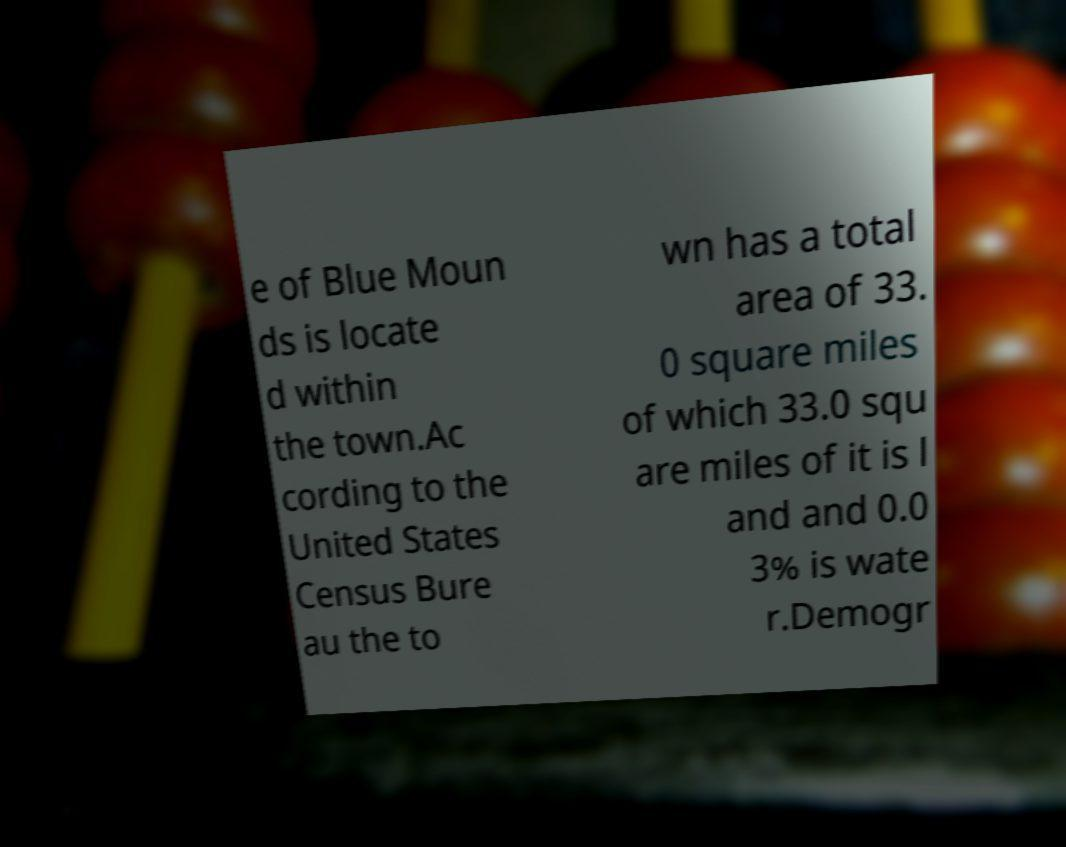Could you assist in decoding the text presented in this image and type it out clearly? e of Blue Moun ds is locate d within the town.Ac cording to the United States Census Bure au the to wn has a total area of 33. 0 square miles of which 33.0 squ are miles of it is l and and 0.0 3% is wate r.Demogr 